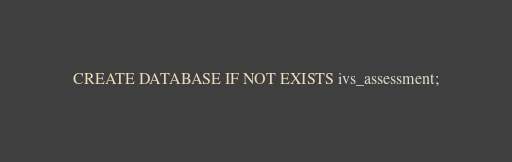Convert code to text. <code><loc_0><loc_0><loc_500><loc_500><_SQL_>CREATE DATABASE IF NOT EXISTS ivs_assessment;
</code> 